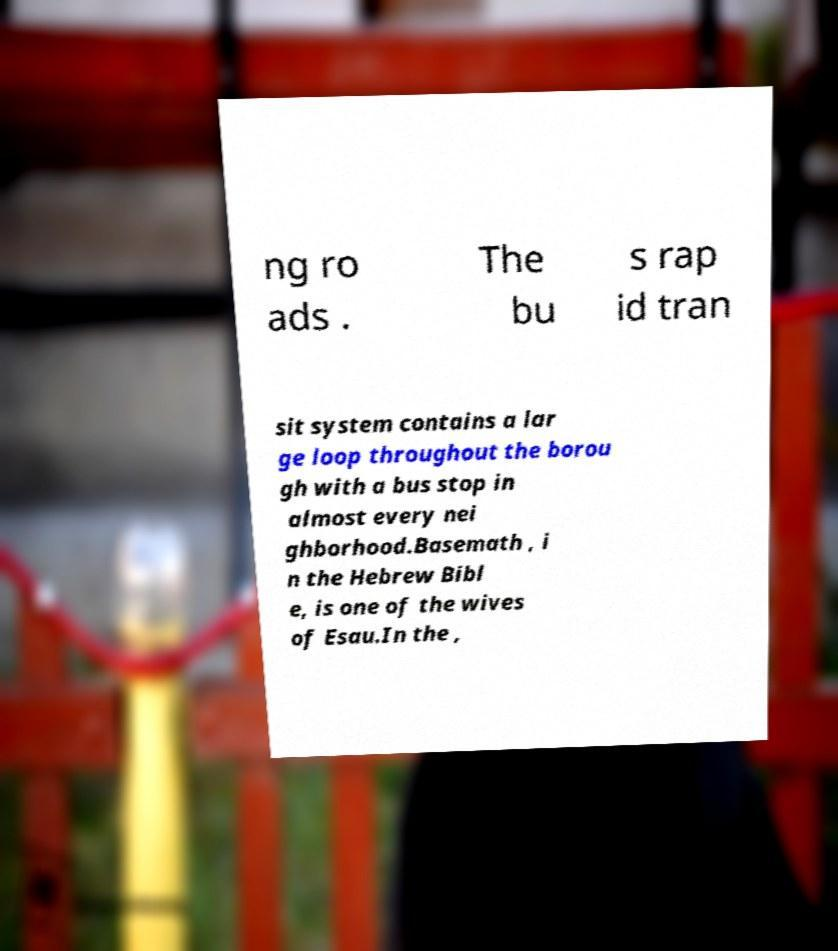Can you accurately transcribe the text from the provided image for me? ng ro ads . The bu s rap id tran sit system contains a lar ge loop throughout the borou gh with a bus stop in almost every nei ghborhood.Basemath , i n the Hebrew Bibl e, is one of the wives of Esau.In the , 